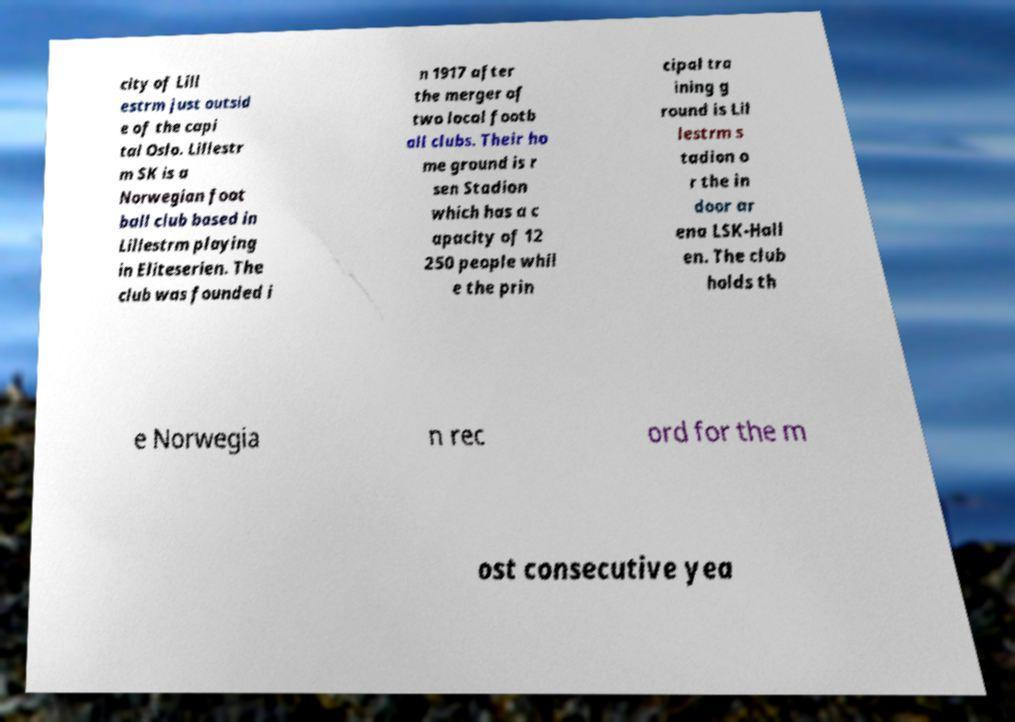I need the written content from this picture converted into text. Can you do that? city of Lill estrm just outsid e of the capi tal Oslo. Lillestr m SK is a Norwegian foot ball club based in Lillestrm playing in Eliteserien. The club was founded i n 1917 after the merger of two local footb all clubs. Their ho me ground is r sen Stadion which has a c apacity of 12 250 people whil e the prin cipal tra ining g round is Lil lestrm s tadion o r the in door ar ena LSK-Hall en. The club holds th e Norwegia n rec ord for the m ost consecutive yea 